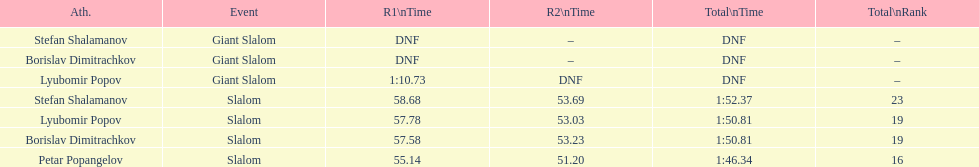How long did it take for lyubomir popov to finish the giant slalom in race 1? 1:10.73. 